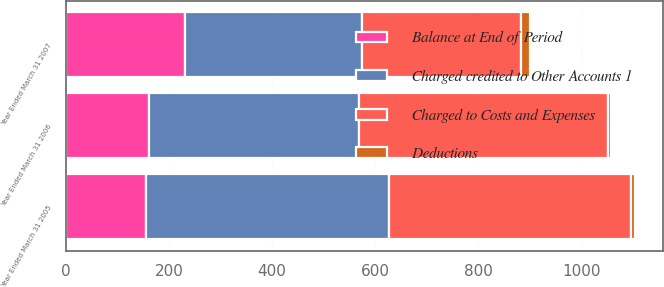Convert chart. <chart><loc_0><loc_0><loc_500><loc_500><stacked_bar_chart><ecel><fcel>Year Ended March 31 2007<fcel>Year Ended March 31 2006<fcel>Year Ended March 31 2005<nl><fcel>Balance at End of Period<fcel>232<fcel>162<fcel>155<nl><fcel>Charged to Costs and Expenses<fcel>308<fcel>483<fcel>471<nl><fcel>Deductions<fcel>17<fcel>6<fcel>7<nl><fcel>Charged credited to Other Accounts 1<fcel>343<fcel>407<fcel>471<nl></chart> 